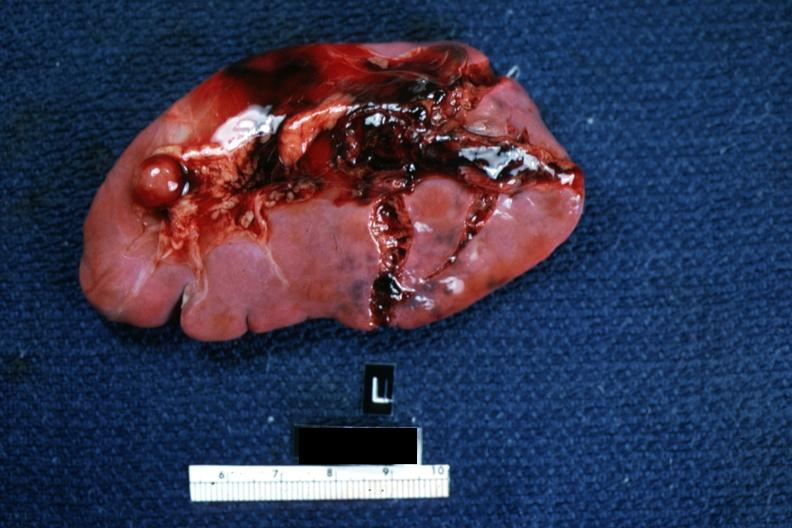does endocervical polyp show typical lacerations?
Answer the question using a single word or phrase. No 